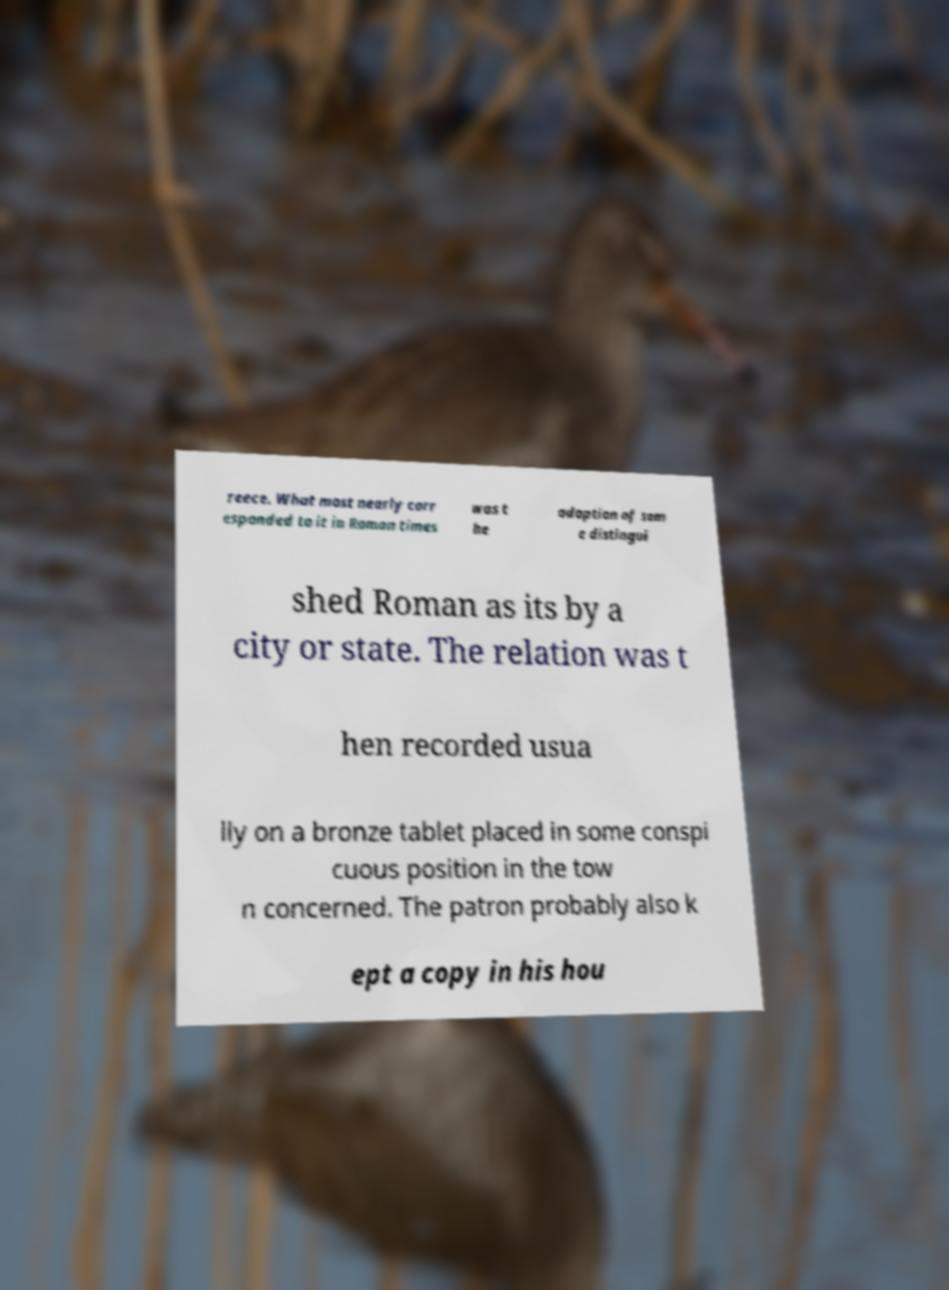Please identify and transcribe the text found in this image. reece. What most nearly corr esponded to it in Roman times was t he adoption of som e distingui shed Roman as its by a city or state. The relation was t hen recorded usua lly on a bronze tablet placed in some conspi cuous position in the tow n concerned. The patron probably also k ept a copy in his hou 